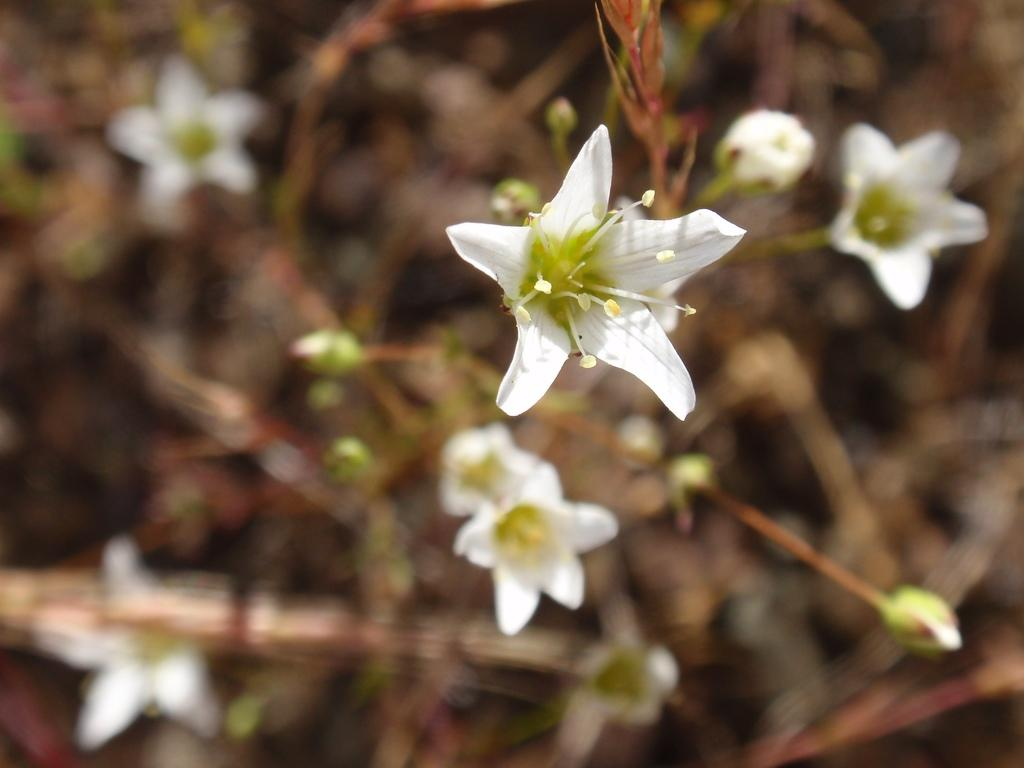What type of flowers can be seen in the foreground of the image? There are white color flowers in the foreground of the image. What stage of growth are the flowers in? There are buds in the foreground of the image. Can you describe the background of the image? The background of the image is blurred. How many members are on the team in the image? There is no team present in the image; it features white color flowers and buds in the foreground. What type of knot can be seen in the image? There is no knot present in the image. 